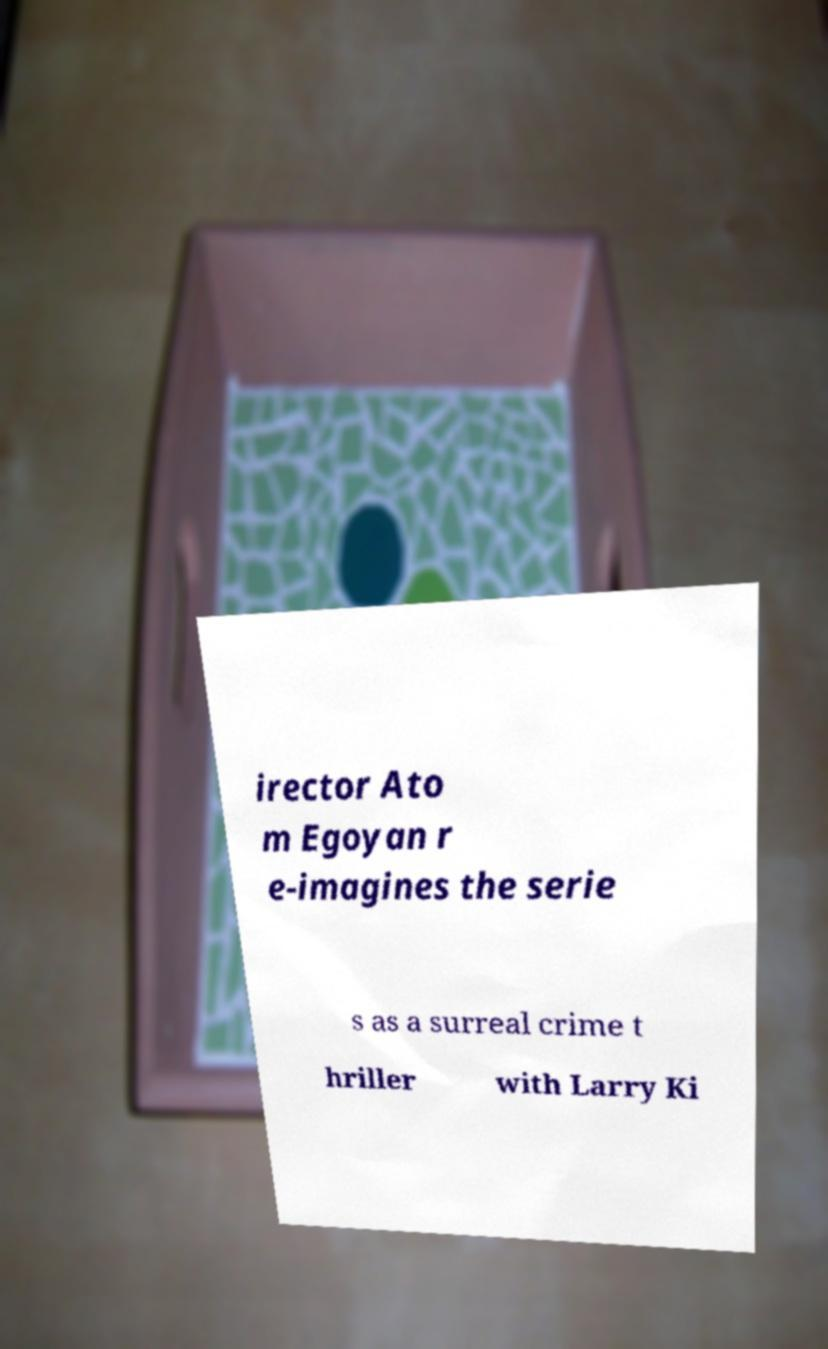Can you read and provide the text displayed in the image?This photo seems to have some interesting text. Can you extract and type it out for me? irector Ato m Egoyan r e-imagines the serie s as a surreal crime t hriller with Larry Ki 